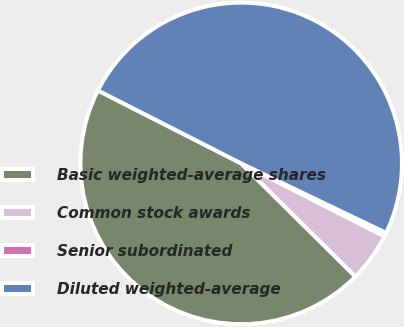Convert chart to OTSL. <chart><loc_0><loc_0><loc_500><loc_500><pie_chart><fcel>Basic weighted-average shares<fcel>Common stock awards<fcel>Senior subordinated<fcel>Diluted weighted-average<nl><fcel>45.07%<fcel>4.93%<fcel>0.38%<fcel>49.62%<nl></chart> 